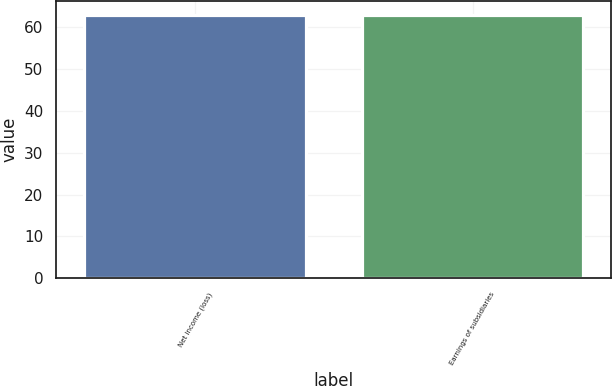Convert chart. <chart><loc_0><loc_0><loc_500><loc_500><bar_chart><fcel>Net income (loss)<fcel>Earnings of subsidiaries<nl><fcel>63<fcel>63.1<nl></chart> 